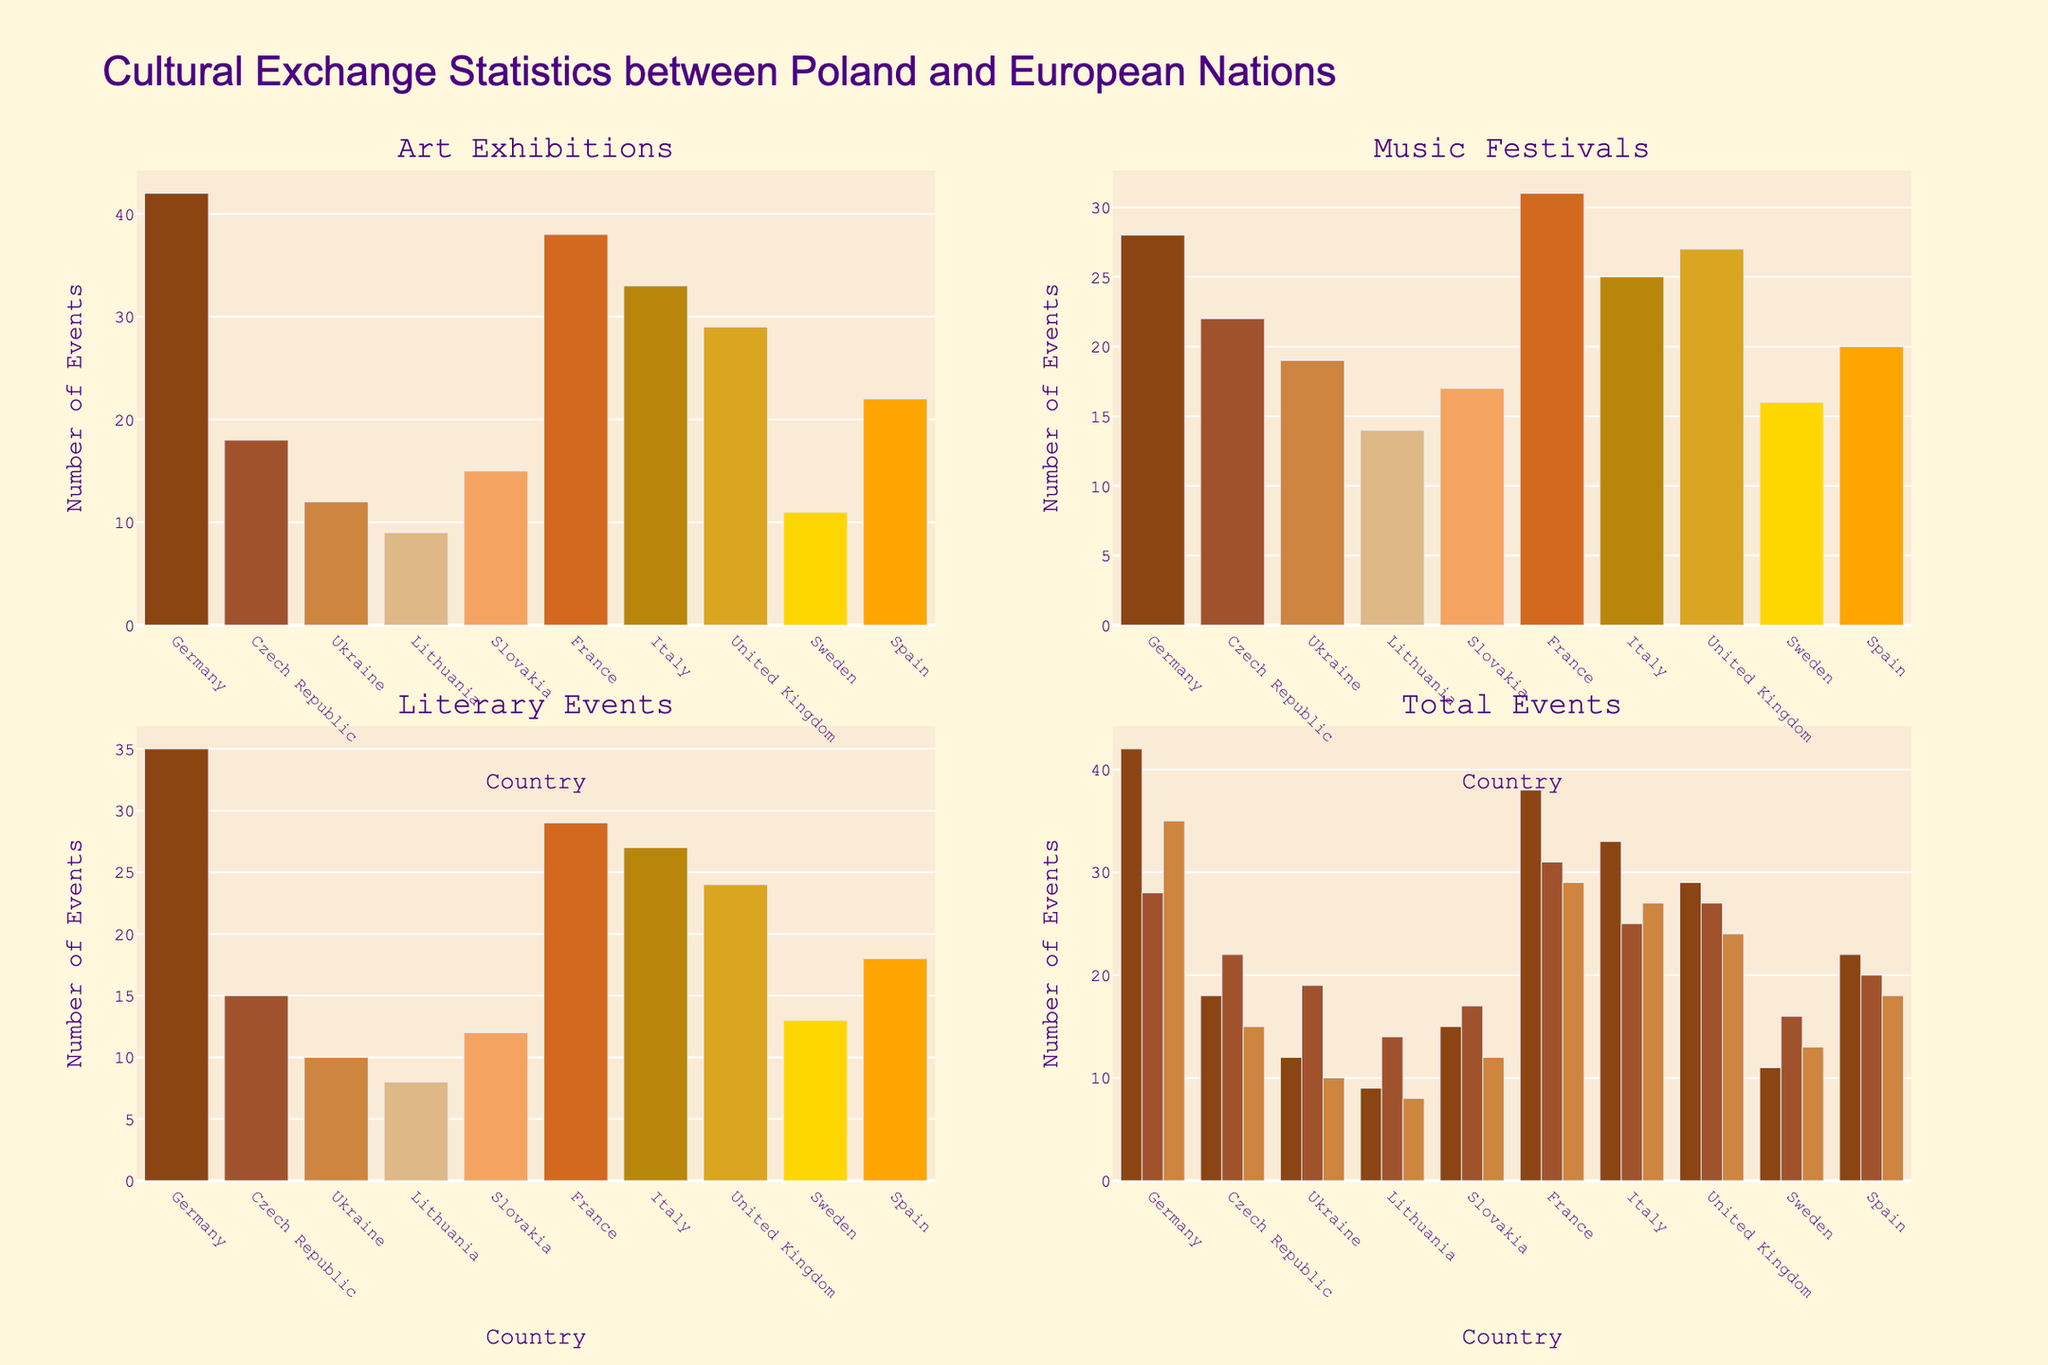what is the title of the figure? The title is displayed at the top of the figure. It reads "Cultural Exchange Statistics between Poland and European Nations."
Answer: Cultural Exchange Statistics between Poland and European Nations How many countries have their data represented in the figure? The x-axis labels represent the countries. Counting them, we find 10 countries.
Answer: 10 Which country has the highest number of art exhibitions? By examining the bar in the "Art Exhibitions" subplot, we observe that Germany has the highest bar, indicating the most art exhibitions.
Answer: Germany Which country has the lowest number of literary events? In the "Literary Events" subplot, the shortest bar belongs to Lithuania, indicating the least literary events.
Answer: Lithuania How many more music festivals does France have compared to Sweden? From the "Music Festivals" subplot, France has 31 festivals, and Sweden has 16. Subtracting these, 31 - 16 = 15.
Answer: 15 Which country has the second highest total number of cultural events? In the "Total Events" subplot (stacked bars), the country with the second tallest combined bar is Italy.
Answer: Italy How many total literary events are represented for all countries combined? Sum the literary events for all countries: 35 + 15 + 10 + 8 + 12 + 29 + 27 + 24 + 13 + 18 = 191.
Answer: 191 Which country has more art exhibitions than music festivals? Comparing the bars in the "Art Exhibitions" and "Music Festivals" subplots, Germany, Czech Republic, France, Italy, and Spain have more art exhibitions than music festivals.
Answer: Germany, Czech Republic, France, Italy, Spain What is the average number of art exhibitions across all countries? Sum the art exhibitions and divide by the number of countries: (42 + 18 + 12 + 9 + 15 + 38 + 33 + 29 + 11 + 22) / 10 = 22.9.
Answer: 22.9 Compare the number of music festivals in Italy and the United Kingdom. Which country has more? The "Music Festivals" subplot shows Italy with 25 festivals and the United Kingdom with 27. The UK has more.
Answer: United Kingdom 